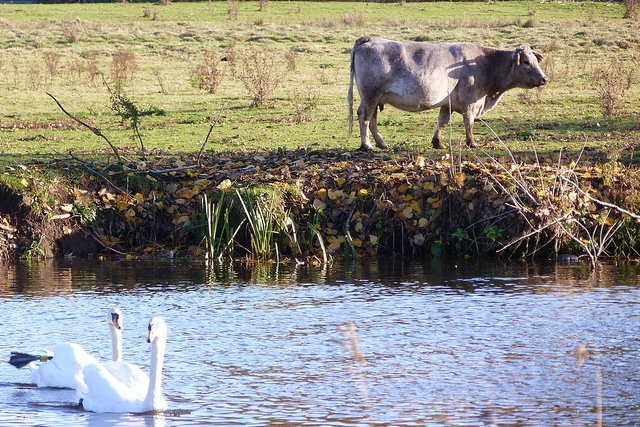Describe the objects in this image and their specific colors. I can see cow in navy, gray, black, lightgray, and darkgray tones, bird in navy, white, lightblue, lavender, and gray tones, and bird in navy, lightblue, white, lavender, and blue tones in this image. 